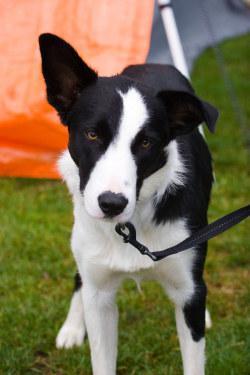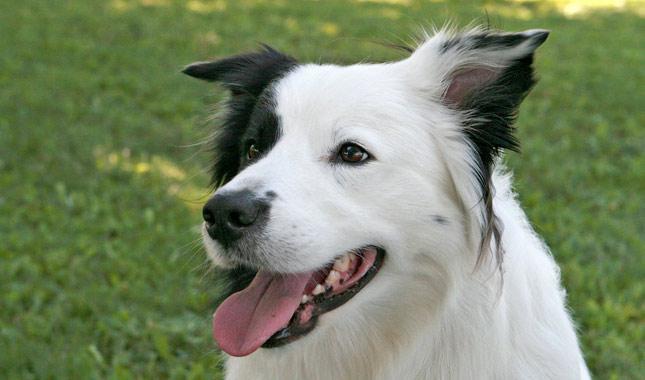The first image is the image on the left, the second image is the image on the right. Considering the images on both sides, is "In one of the images there is a dog standing in the grass and looking away from the camera." valid? Answer yes or no. No. The first image is the image on the left, the second image is the image on the right. Examine the images to the left and right. Is the description "Right image shows a dog standing on grass, with its body turned rightward." accurate? Answer yes or no. No. 